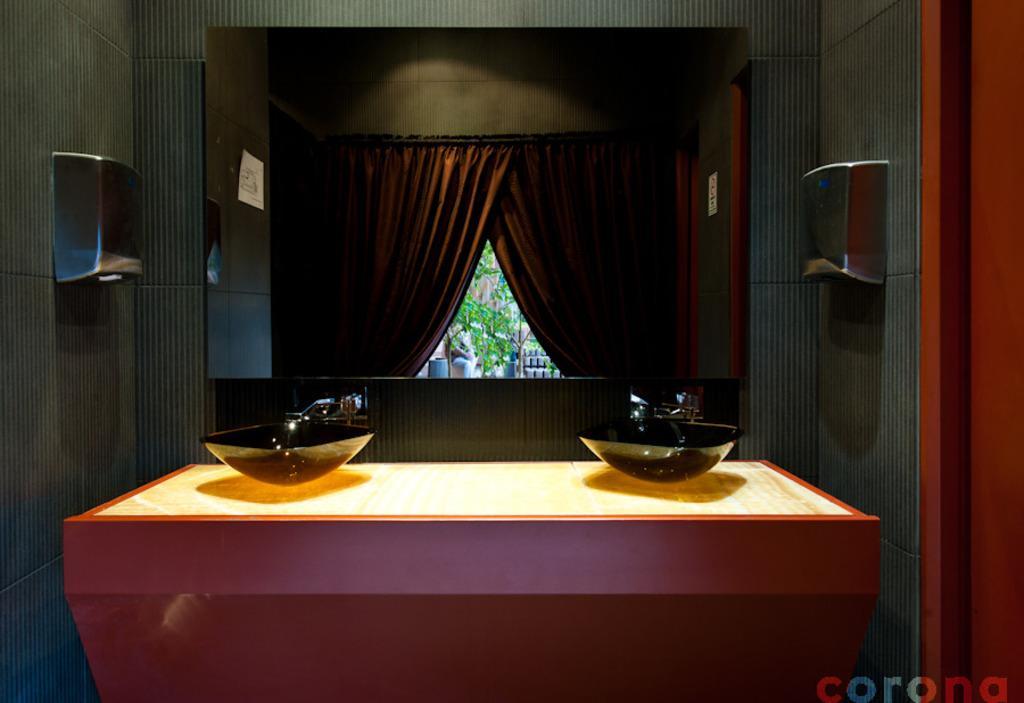In one or two sentences, can you explain what this image depicts? In this image I can see a room and I can see a table, on the table I can see two bowls and I can see a curtain and wall visible in the middle. 